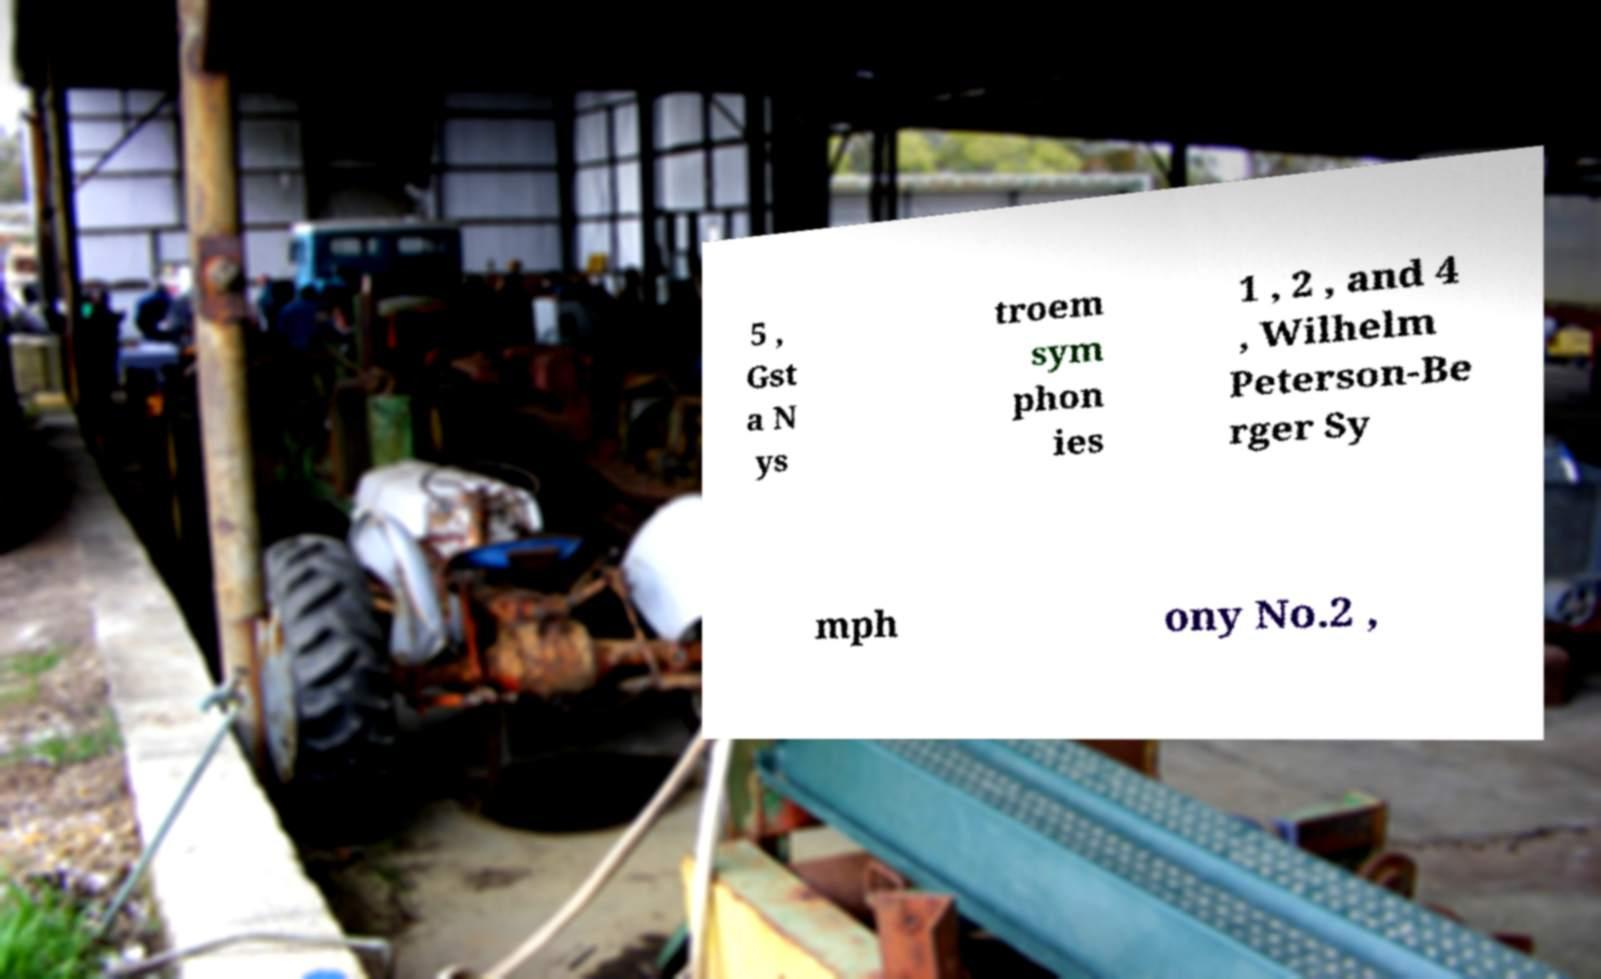Can you read and provide the text displayed in the image?This photo seems to have some interesting text. Can you extract and type it out for me? 5 , Gst a N ys troem sym phon ies 1 , 2 , and 4 , Wilhelm Peterson-Be rger Sy mph ony No.2 , 